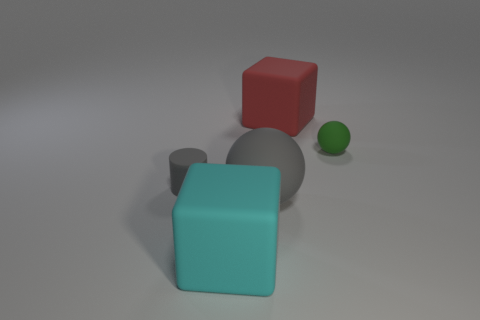How many objects are spheres that are in front of the gray matte cylinder or purple metallic cylinders?
Your response must be concise. 1. Is the material of the green thing the same as the large red block behind the cyan rubber thing?
Offer a very short reply. Yes. What number of other objects are the same shape as the large red thing?
Your answer should be very brief. 1. How many things are either matte objects that are right of the small gray cylinder or large rubber cubes that are left of the red block?
Your answer should be very brief. 4. How many other things are there of the same color as the tiny matte cylinder?
Your answer should be very brief. 1. Are there fewer large red blocks that are to the left of the red matte block than rubber cylinders that are behind the cylinder?
Keep it short and to the point. No. What number of cubes are there?
Your answer should be very brief. 2. Is there any other thing that is the same material as the large cyan cube?
Your response must be concise. Yes. There is a big object that is the same shape as the small green thing; what is its material?
Give a very brief answer. Rubber. Are there fewer green objects in front of the large cyan block than small spheres?
Offer a very short reply. Yes. 